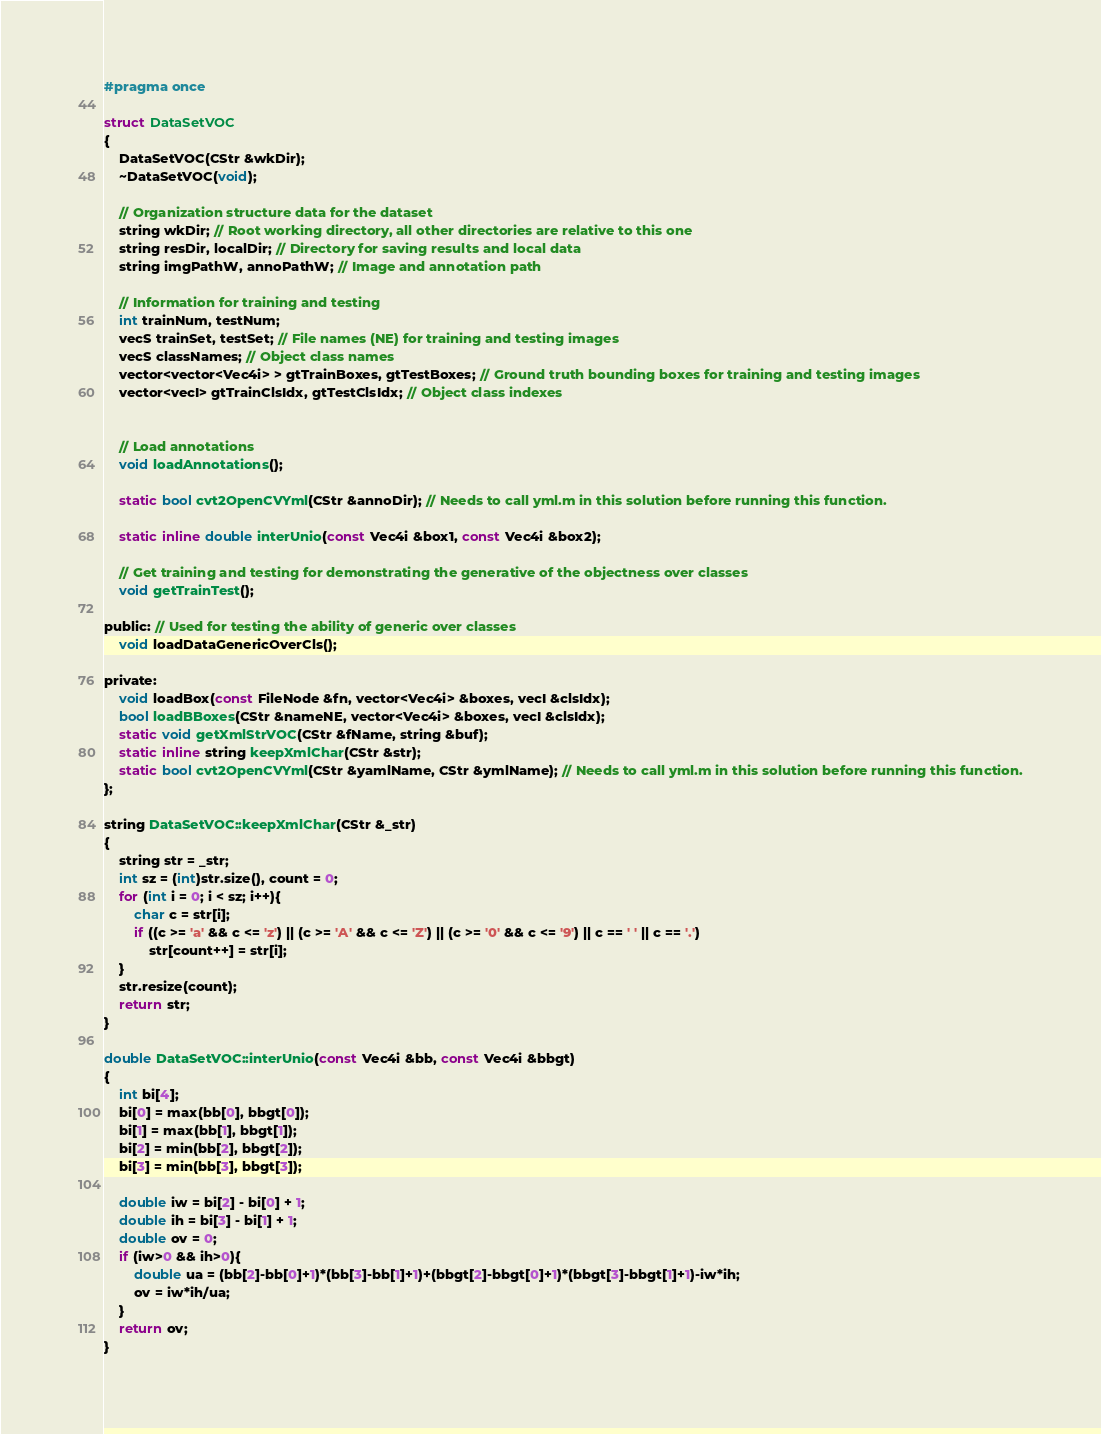Convert code to text. <code><loc_0><loc_0><loc_500><loc_500><_C_>#pragma once

struct DataSetVOC
{
	DataSetVOC(CStr &wkDir);
	~DataSetVOC(void);

	// Organization structure data for the dataset
	string wkDir; // Root working directory, all other directories are relative to this one
	string resDir, localDir; // Directory for saving results and local data
	string imgPathW, annoPathW; // Image and annotation path

	// Information for training and testing
	int trainNum, testNum;
	vecS trainSet, testSet; // File names (NE) for training and testing images
	vecS classNames; // Object class names
	vector<vector<Vec4i> > gtTrainBoxes, gtTestBoxes; // Ground truth bounding boxes for training and testing images
	vector<vecI> gtTrainClsIdx, gtTestClsIdx; // Object class indexes  


	// Load annotations
	void loadAnnotations();

	static bool cvt2OpenCVYml(CStr &annoDir); // Needs to call yml.m in this solution before running this function.

	static inline double interUnio(const Vec4i &box1, const Vec4i &box2);

	// Get training and testing for demonstrating the generative of the objectness over classes
	void getTrainTest(); 

public: // Used for testing the ability of generic over classes
	void loadDataGenericOverCls();

private:
    void loadBox(const FileNode &fn, vector<Vec4i> &boxes, vecI &clsIdx);
	bool loadBBoxes(CStr &nameNE, vector<Vec4i> &boxes, vecI &clsIdx);
	static void getXmlStrVOC(CStr &fName, string &buf);
	static inline string keepXmlChar(CStr &str);
	static bool cvt2OpenCVYml(CStr &yamlName, CStr &ymlName); // Needs to call yml.m in this solution before running this function.
};

string DataSetVOC::keepXmlChar(CStr &_str)
{
	string str = _str;
	int sz = (int)str.size(), count = 0;
	for (int i = 0; i < sz; i++){
		char c = str[i];
		if ((c >= 'a' && c <= 'z') || (c >= 'A' && c <= 'Z') || (c >= '0' && c <= '9') || c == ' ' || c == '.')
			str[count++] = str[i];
	}
	str.resize(count);
	return str;
}

double DataSetVOC::interUnio(const Vec4i &bb, const Vec4i &bbgt)
{
	int bi[4];
	bi[0] = max(bb[0], bbgt[0]);
	bi[1] = max(bb[1], bbgt[1]);
	bi[2] = min(bb[2], bbgt[2]);
	bi[3] = min(bb[3], bbgt[3]);	

	double iw = bi[2] - bi[0] + 1;
	double ih = bi[3] - bi[1] + 1;
	double ov = 0;
	if (iw>0 && ih>0){
		double ua = (bb[2]-bb[0]+1)*(bb[3]-bb[1]+1)+(bbgt[2]-bbgt[0]+1)*(bbgt[3]-bbgt[1]+1)-iw*ih;
		ov = iw*ih/ua;
	}	
	return ov;
}
</code> 